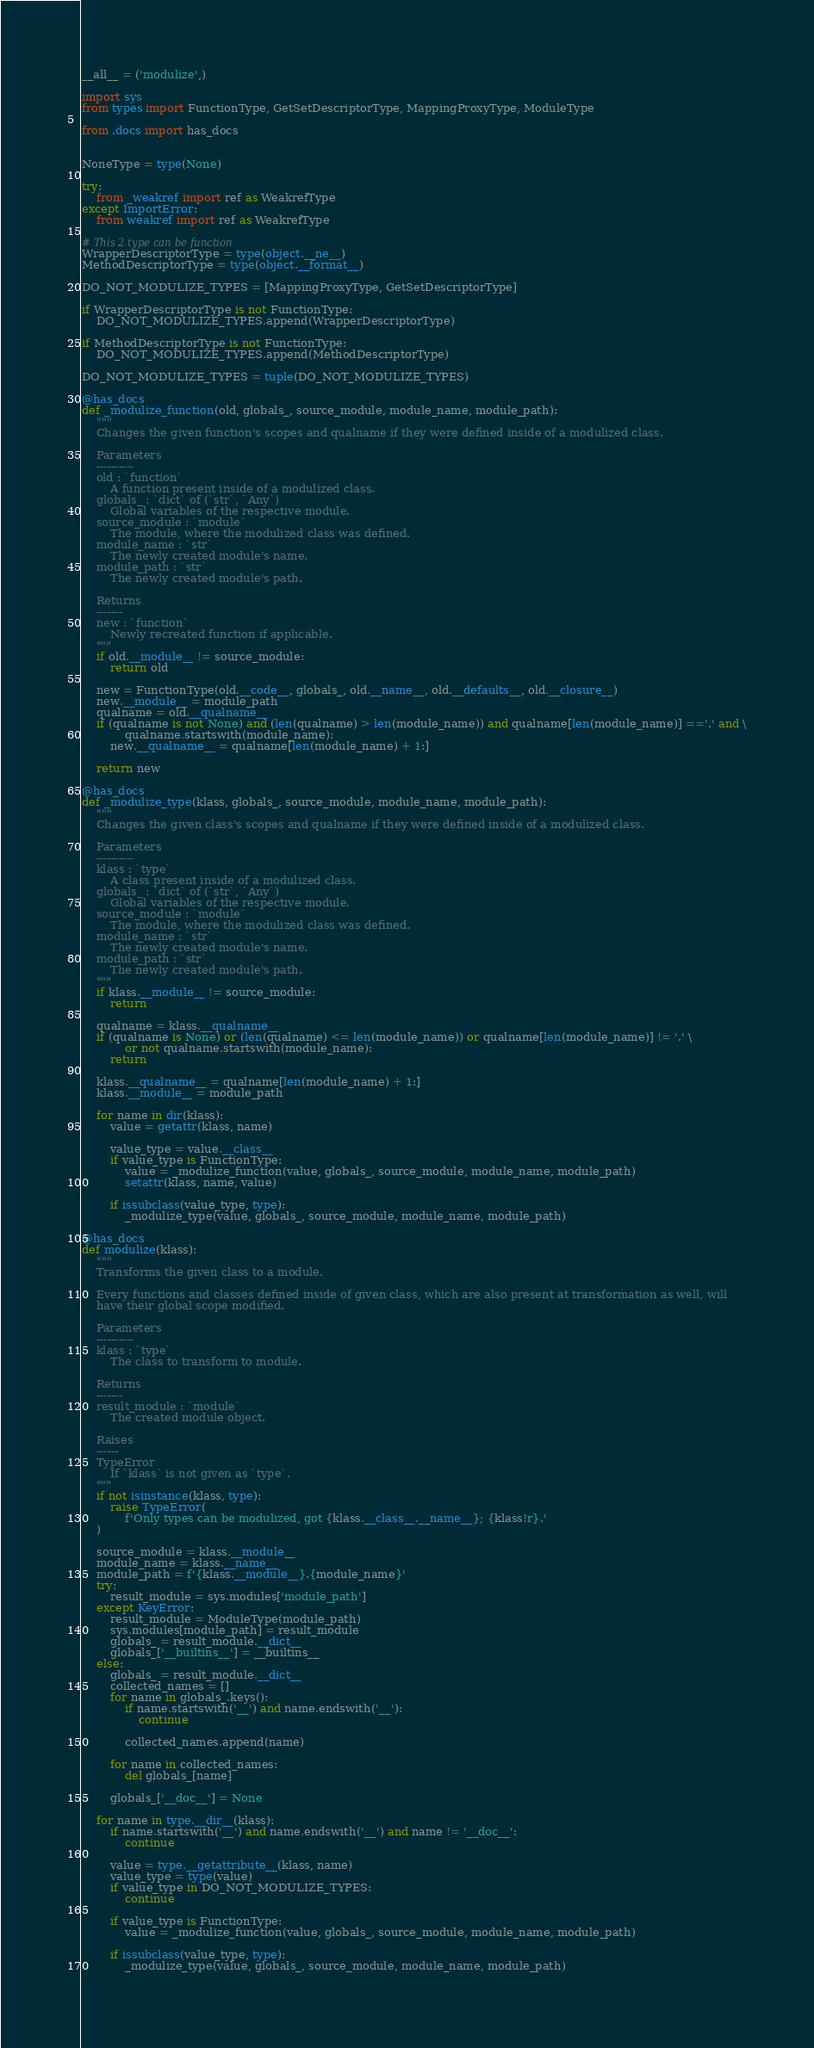<code> <loc_0><loc_0><loc_500><loc_500><_Python_>__all__ = ('modulize',)

import sys
from types import FunctionType, GetSetDescriptorType, MappingProxyType, ModuleType

from .docs import has_docs


NoneType = type(None)

try:
    from _weakref import ref as WeakrefType
except ImportError:
    from weakref import ref as WeakrefType

# This 2 type can be function
WrapperDescriptorType = type(object.__ne__)
MethodDescriptorType = type(object.__format__)

DO_NOT_MODULIZE_TYPES = [MappingProxyType, GetSetDescriptorType]

if WrapperDescriptorType is not FunctionType:
    DO_NOT_MODULIZE_TYPES.append(WrapperDescriptorType)

if MethodDescriptorType is not FunctionType:
    DO_NOT_MODULIZE_TYPES.append(MethodDescriptorType)

DO_NOT_MODULIZE_TYPES = tuple(DO_NOT_MODULIZE_TYPES)

@has_docs
def _modulize_function(old, globals_, source_module, module_name, module_path):
    """
    Changes the given function's scopes and qualname if they were defined inside of a modulized class.
    
    Parameters
    ----------
    old : `function`
        A function present inside of a modulized class.
    globals_ : `dict` of (`str`, `Any`)
        Global variables of the respective module.
    source_module : `module`
        The module, where the modulized class was defined.
    module_name : `str`
        The newly created module's name.
    module_path : `str`
        The newly created module's path.

    Returns
    -------
    new : `function`
        Newly recreated function if applicable.
    """
    if old.__module__ != source_module:
        return old
    
    new = FunctionType(old.__code__, globals_, old.__name__, old.__defaults__, old.__closure__)
    new.__module__ = module_path
    qualname = old.__qualname__
    if (qualname is not None) and (len(qualname) > len(module_name)) and qualname[len(module_name)] =='.' and \
            qualname.startswith(module_name):
        new.__qualname__ = qualname[len(module_name) + 1:]
    
    return new

@has_docs
def _modulize_type(klass, globals_, source_module, module_name, module_path):
    """
    Changes the given class's scopes and qualname if they were defined inside of a modulized class.
    
    Parameters
    ----------
    klass : `type`
        A class present inside of a modulized class.
    globals_ : `dict` of (`str`, `Any`)
        Global variables of the respective module.
    source_module : `module`
        The module, where the modulized class was defined.
    module_name : `str`
        The newly created module's name.
    module_path : `str`
        The newly created module's path.
    """
    if klass.__module__ != source_module:
        return
    
    qualname = klass.__qualname__
    if (qualname is None) or (len(qualname) <= len(module_name)) or qualname[len(module_name)] != '.' \
            or not qualname.startswith(module_name):
        return
    
    klass.__qualname__ = qualname[len(module_name) + 1:]
    klass.__module__ = module_path
    
    for name in dir(klass):
        value = getattr(klass, name)
        
        value_type = value.__class__
        if value_type is FunctionType:
            value = _modulize_function(value, globals_, source_module, module_name, module_path)
            setattr(klass, name, value)
        
        if issubclass(value_type, type):
            _modulize_type(value, globals_, source_module, module_name, module_path)

@has_docs
def modulize(klass):
    """
    Transforms the given class to a module.
    
    Every functions and classes defined inside of given class, which are also present at transformation as well, will
    have their global scope modified.
    
    Parameters
    ----------
    klass : `type`
        The class to transform to module.
    
    Returns
    -------
    result_module : `module`
        The created module object.
    
    Raises
    ------
    TypeError
        If `klass` is not given as `type`.
    """
    if not isinstance(klass, type):
        raise TypeError(
            f'Only types can be modulized, got {klass.__class__.__name__}; {klass!r}.'
    )
    
    source_module = klass.__module__
    module_name = klass.__name__
    module_path = f'{klass.__module__}.{module_name}'
    try:
        result_module = sys.modules['module_path']
    except KeyError:
        result_module = ModuleType(module_path)
        sys.modules[module_path] = result_module
        globals_ = result_module.__dict__
        globals_['__builtins__'] = __builtins__
    else:
        globals_ = result_module.__dict__
        collected_names = []
        for name in globals_.keys():
            if name.startswith('__') and name.endswith('__'):
                continue
            
            collected_names.append(name)
        
        for name in collected_names:
            del globals_[name]
        
        globals_['__doc__'] = None
    
    for name in type.__dir__(klass):
        if name.startswith('__') and name.endswith('__') and name != '__doc__':
            continue
        
        value = type.__getattribute__(klass, name)
        value_type = type(value)
        if value_type in DO_NOT_MODULIZE_TYPES:
            continue
        
        if value_type is FunctionType:
            value = _modulize_function(value, globals_, source_module, module_name, module_path)
        
        if issubclass(value_type, type):
            _modulize_type(value, globals_, source_module, module_name, module_path)
        </code> 